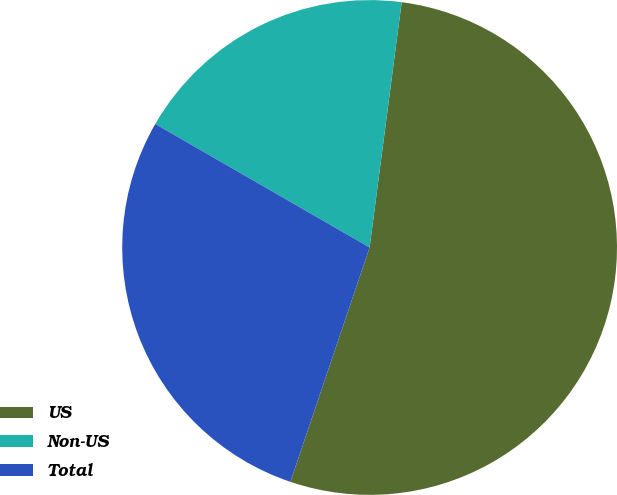Convert chart to OTSL. <chart><loc_0><loc_0><loc_500><loc_500><pie_chart><fcel>US<fcel>Non-US<fcel>Total<nl><fcel>53.12%<fcel>18.75%<fcel>28.13%<nl></chart> 